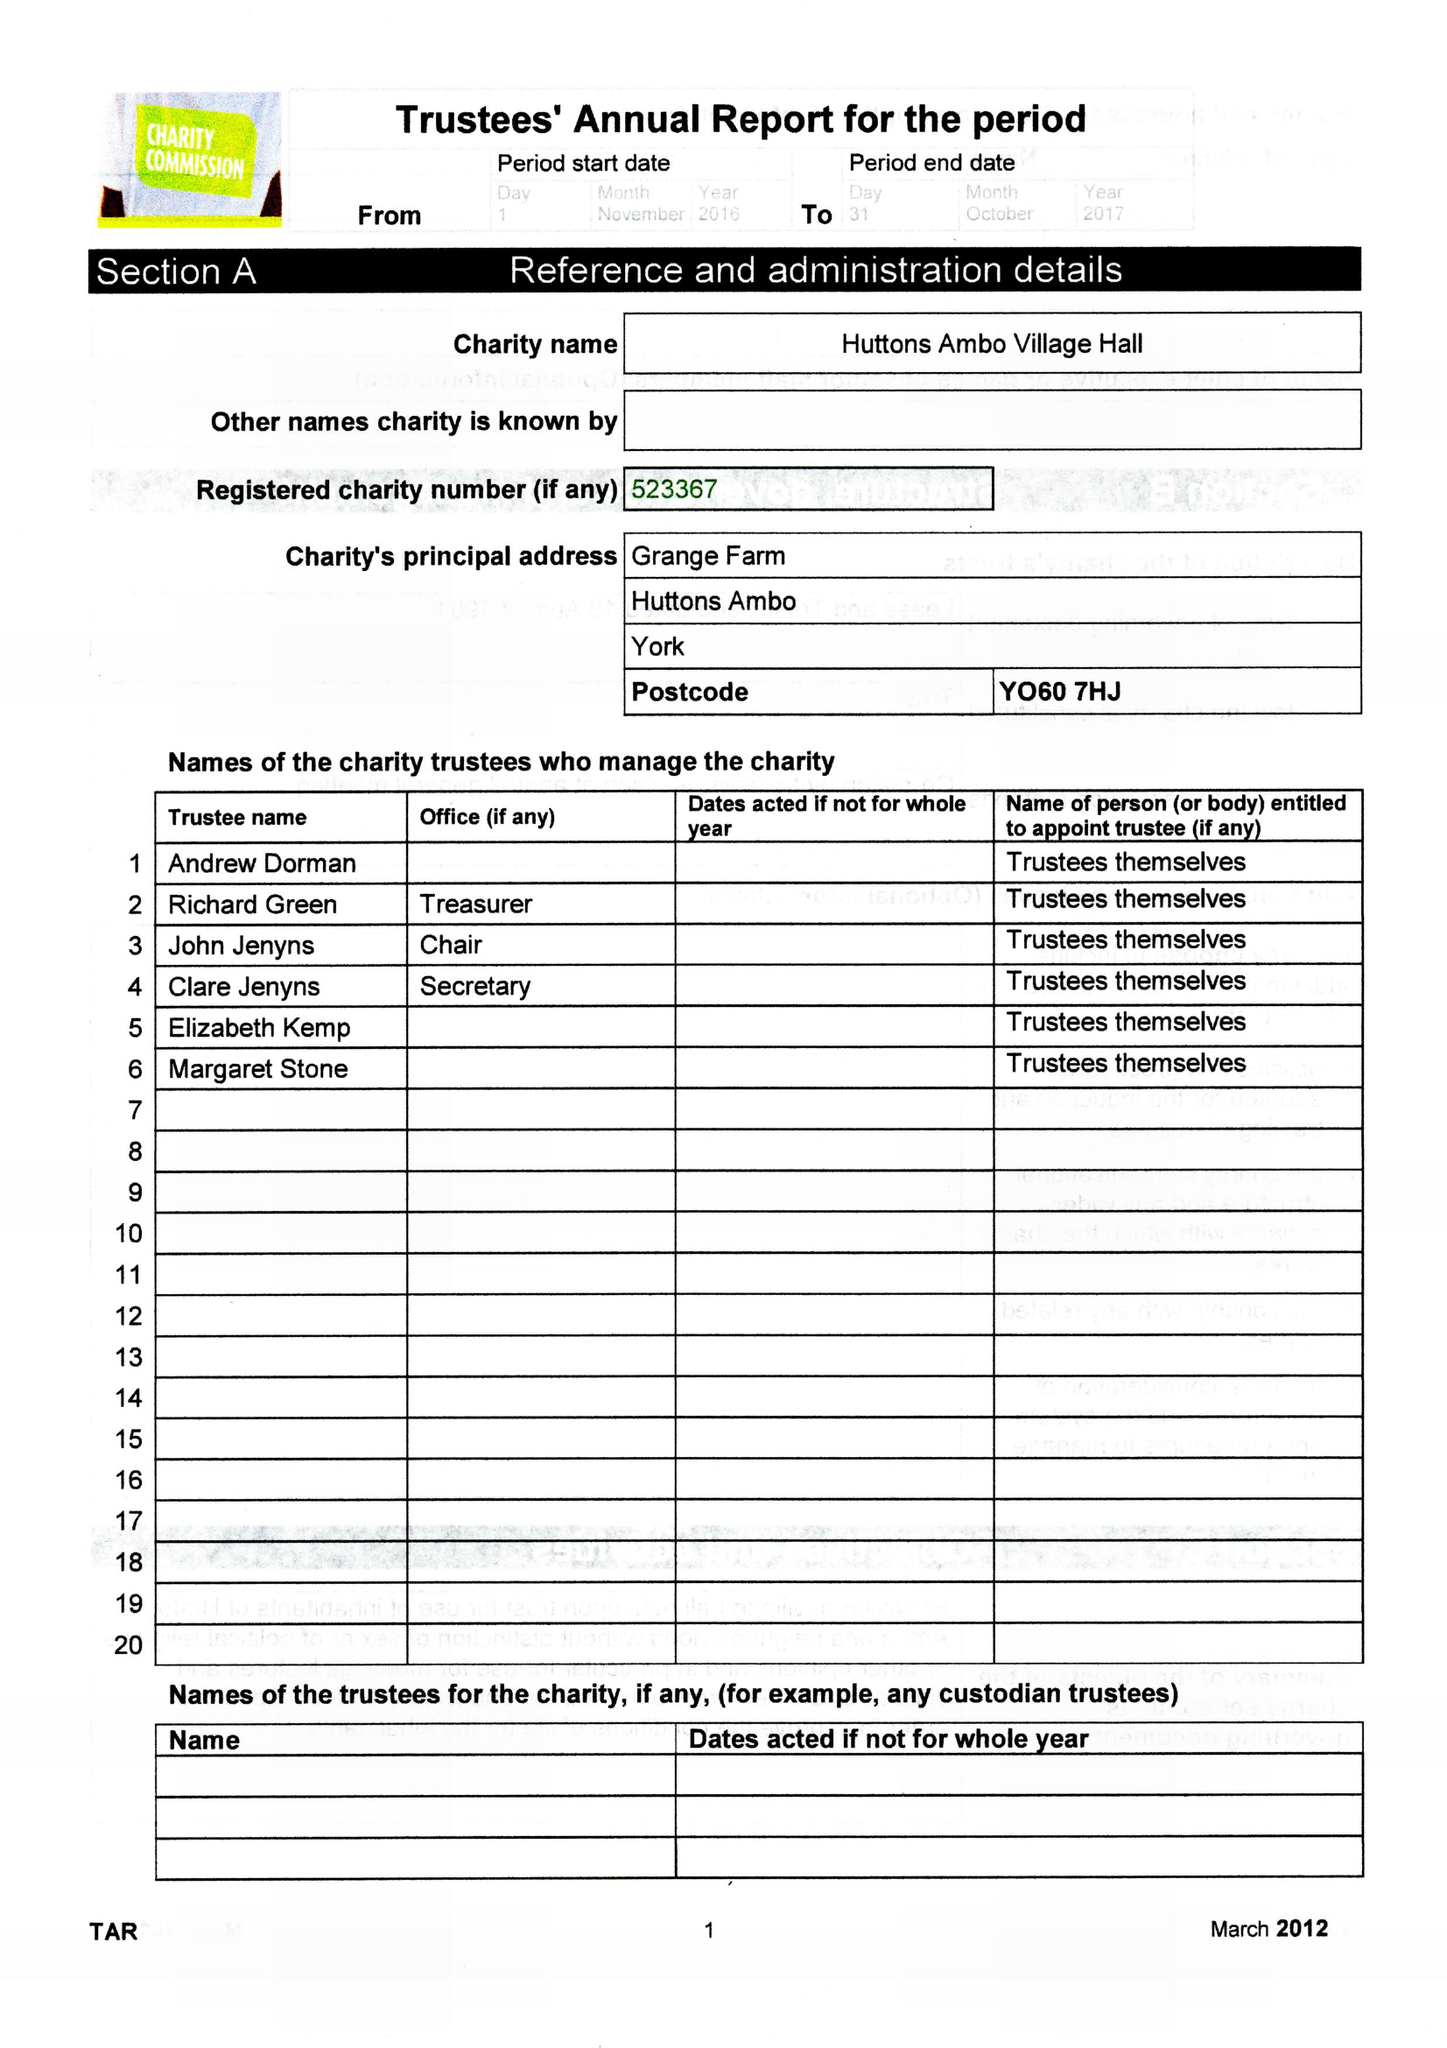What is the value for the address__post_town?
Answer the question using a single word or phrase. YORK 